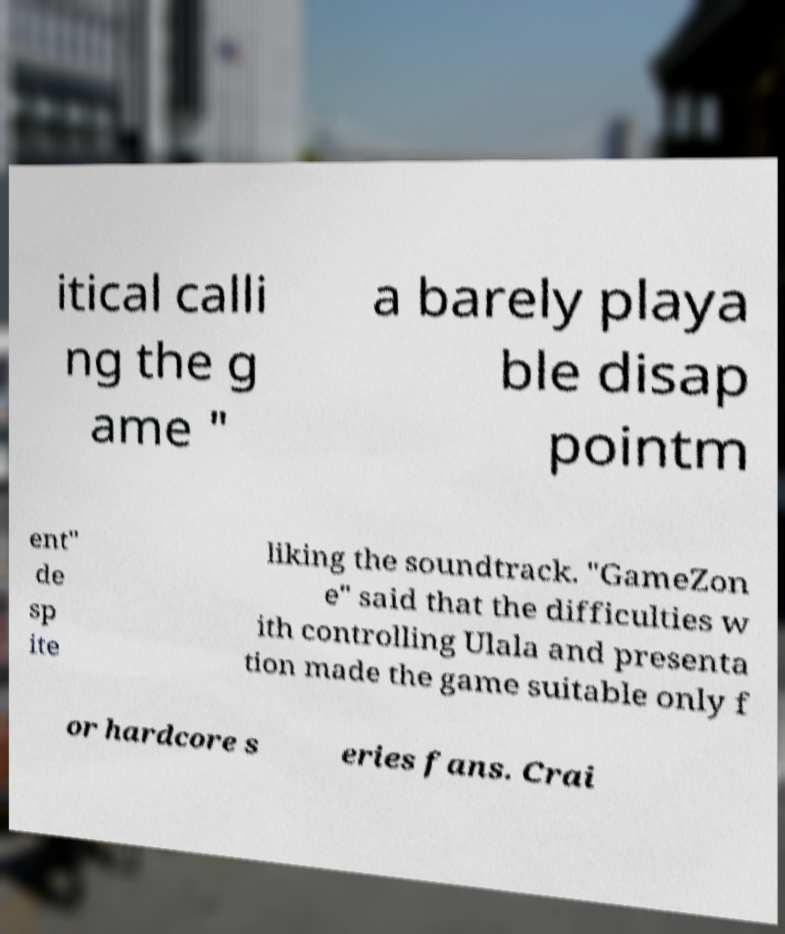For documentation purposes, I need the text within this image transcribed. Could you provide that? itical calli ng the g ame " a barely playa ble disap pointm ent" de sp ite liking the soundtrack. "GameZon e" said that the difficulties w ith controlling Ulala and presenta tion made the game suitable only f or hardcore s eries fans. Crai 